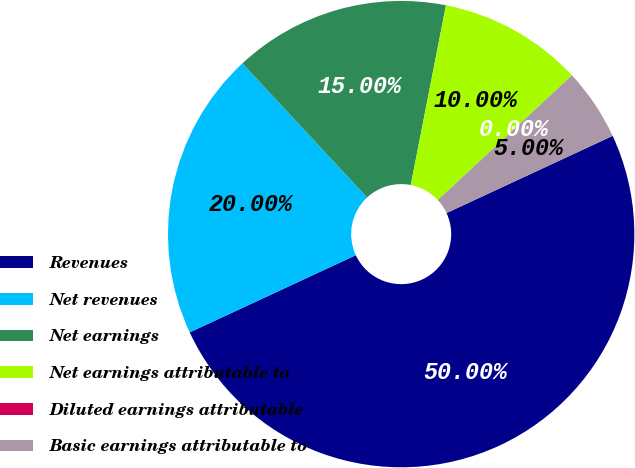Convert chart. <chart><loc_0><loc_0><loc_500><loc_500><pie_chart><fcel>Revenues<fcel>Net revenues<fcel>Net earnings<fcel>Net earnings attributable to<fcel>Diluted earnings attributable<fcel>Basic earnings attributable to<nl><fcel>50.0%<fcel>20.0%<fcel>15.0%<fcel>10.0%<fcel>0.0%<fcel>5.0%<nl></chart> 